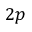Convert formula to latex. <formula><loc_0><loc_0><loc_500><loc_500>2 p</formula> 